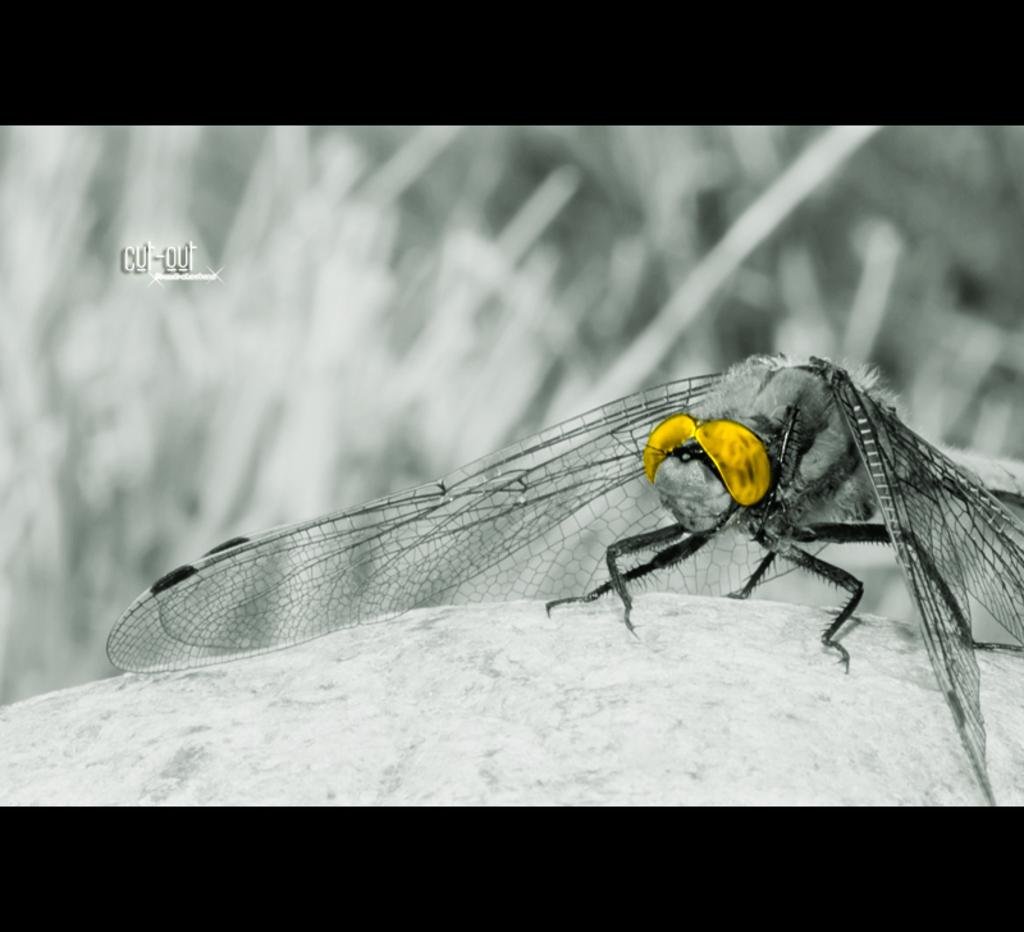What type of insect is in the image? There is a dragonfly in the image. What colors can be seen on the dragonfly? The dragonfly has silver and gold colors. What arithmetic problem is the dragonfly solving in the image? There is no arithmetic problem present in the image; it features a dragonfly with silver and gold colors. What type of rule is the dragonfly enforcing in the image? There is no rule enforcement present in the image; it features a dragonfly with silver and gold colors. 